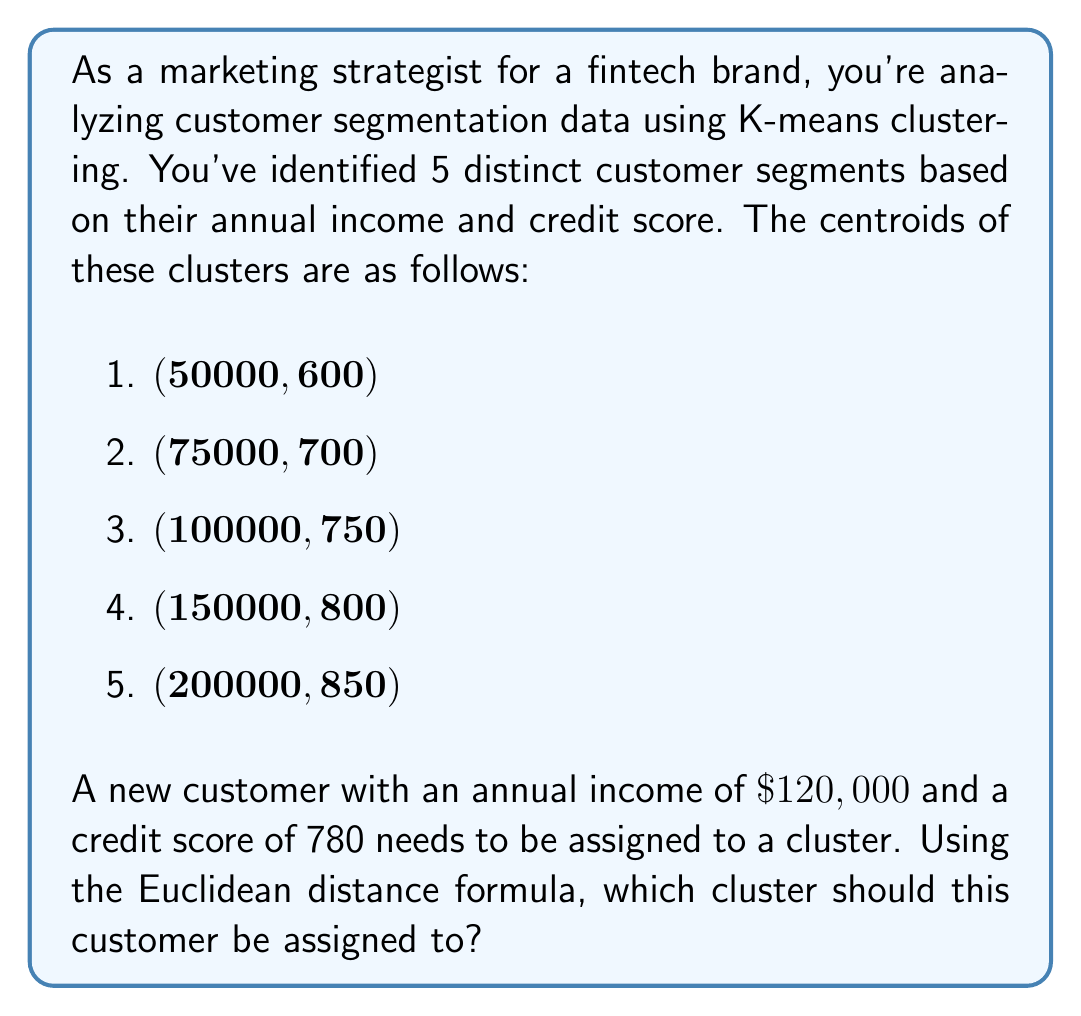Teach me how to tackle this problem. To solve this problem, we need to calculate the Euclidean distance between the new customer's data point and each of the cluster centroids, then assign the customer to the cluster with the shortest distance.

The Euclidean distance formula in two dimensions is:

$$d = \sqrt{(x_2 - x_1)^2 + (y_2 - y_1)^2}$$

Where $(x_1, y_1)$ is the centroid and $(x_2, y_2)$ is the new customer's data point.

Let's calculate the distance to each centroid:

1. For centroid (50000, 600):
   $$d_1 = \sqrt{(120000 - 50000)^2 + (780 - 600)^2} = 70,007.14$$

2. For centroid (75000, 700):
   $$d_2 = \sqrt{(120000 - 75000)^2 + (780 - 700)^2} = 45,027.76$$

3. For centroid (100000, 750):
   $$d_3 = \sqrt{(120000 - 100000)^2 + (780 - 750)^2} = 20,024.98$$

4. For centroid (150000, 800):
   $$d_4 = \sqrt{(120000 - 150000)^2 + (780 - 800)^2} = 30,016.66$$

5. For centroid (200000, 850):
   $$d_5 = \sqrt{(120000 - 200000)^2 + (780 - 850)^2} = 80,038.47$$

The shortest distance is $d_3 = 20,024.98$, which corresponds to cluster 3 with centroid (100000, 750).
Answer: The new customer should be assigned to cluster 3, with centroid (100000, 750). 